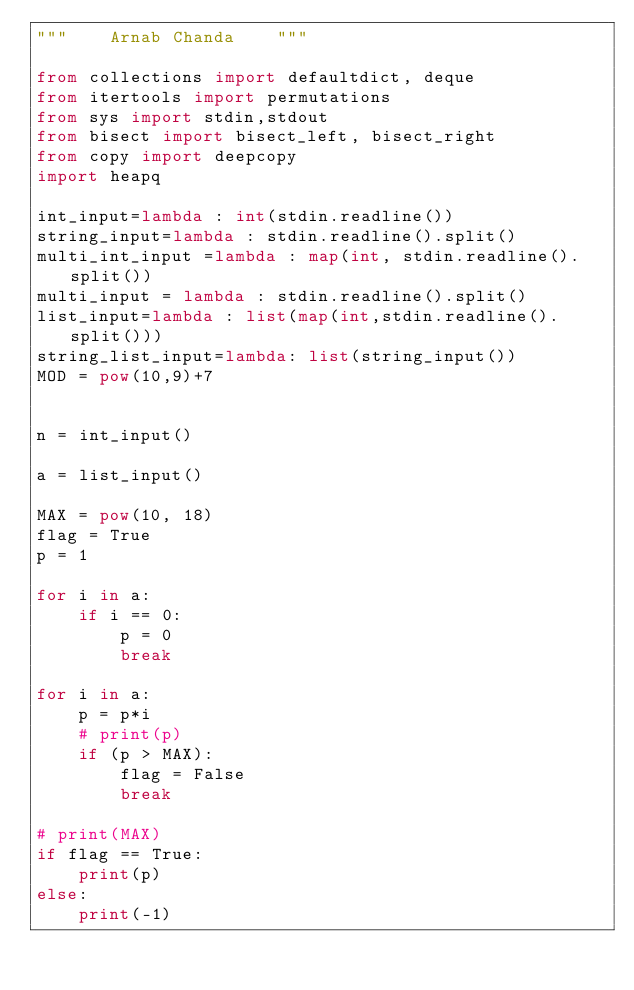Convert code to text. <code><loc_0><loc_0><loc_500><loc_500><_Python_>"""    Arnab Chanda    """

from collections import defaultdict, deque
from itertools import permutations
from sys import stdin,stdout
from bisect import bisect_left, bisect_right
from copy import deepcopy
import heapq

int_input=lambda : int(stdin.readline())
string_input=lambda : stdin.readline().split()
multi_int_input =lambda : map(int, stdin.readline().split())
multi_input = lambda : stdin.readline().split()
list_input=lambda : list(map(int,stdin.readline().split()))
string_list_input=lambda: list(string_input())
MOD = pow(10,9)+7


n = int_input()

a = list_input()

MAX = pow(10, 18)
flag = True
p = 1

for i in a:
    if i == 0:
        p = 0
        break

for i in a:
    p = p*i
    # print(p)
    if (p > MAX):
        flag = False
        break

# print(MAX)
if flag == True:
    print(p)
else:
    print(-1)</code> 